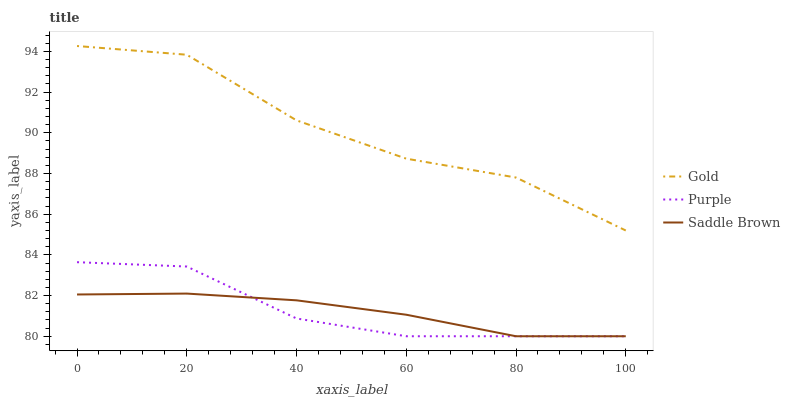Does Gold have the minimum area under the curve?
Answer yes or no. No. Does Saddle Brown have the maximum area under the curve?
Answer yes or no. No. Is Gold the smoothest?
Answer yes or no. No. Is Saddle Brown the roughest?
Answer yes or no. No. Does Gold have the lowest value?
Answer yes or no. No. Does Saddle Brown have the highest value?
Answer yes or no. No. Is Saddle Brown less than Gold?
Answer yes or no. Yes. Is Gold greater than Purple?
Answer yes or no. Yes. Does Saddle Brown intersect Gold?
Answer yes or no. No. 